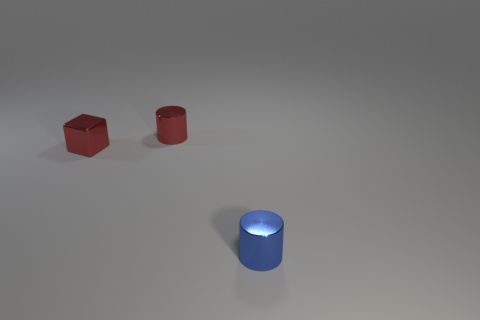Subtract all blue cylinders. How many cylinders are left? 1 Subtract 1 blocks. How many blocks are left? 0 Add 1 red cylinders. How many objects exist? 4 Subtract all cylinders. How many objects are left? 1 Add 2 red spheres. How many red spheres exist? 2 Subtract 0 gray cubes. How many objects are left? 3 Subtract all gray cubes. Subtract all green balls. How many cubes are left? 1 Subtract all cyan blocks. How many yellow cylinders are left? 0 Subtract all purple metallic cylinders. Subtract all tiny metal cylinders. How many objects are left? 1 Add 1 tiny cylinders. How many tiny cylinders are left? 3 